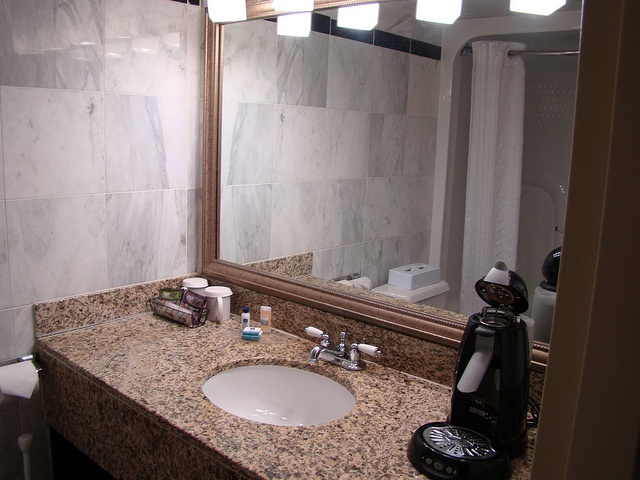Describe the objects in this image and their specific colors. I can see sink in gray and darkgray tones, sink in gray, darkgray, and lightgray tones, cup in gray, darkgray, and lightgray tones, and cup in gray, lightgray, and darkgray tones in this image. 